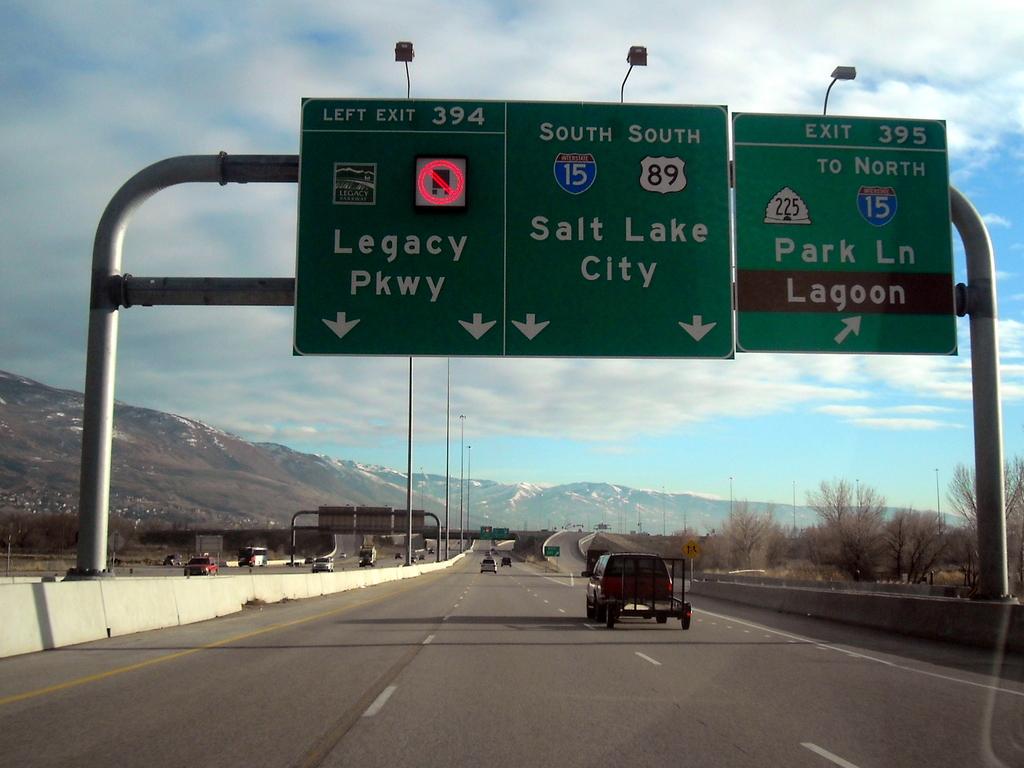Which city is shown?
Keep it short and to the point. Salt lake city. 